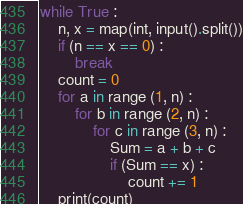Convert code to text. <code><loc_0><loc_0><loc_500><loc_500><_Python_>while True :
    n, x = map(int, input().split())
    if (n == x == 0) :
        break
    count = 0
    for a in range (1, n) :
        for b in range (2, n) :
            for c in range (3, n) :
                Sum = a + b + c
                if (Sum == x) :
                    count += 1
    print(count)</code> 